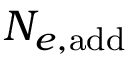Convert formula to latex. <formula><loc_0><loc_0><loc_500><loc_500>N _ { e , a d d }</formula> 